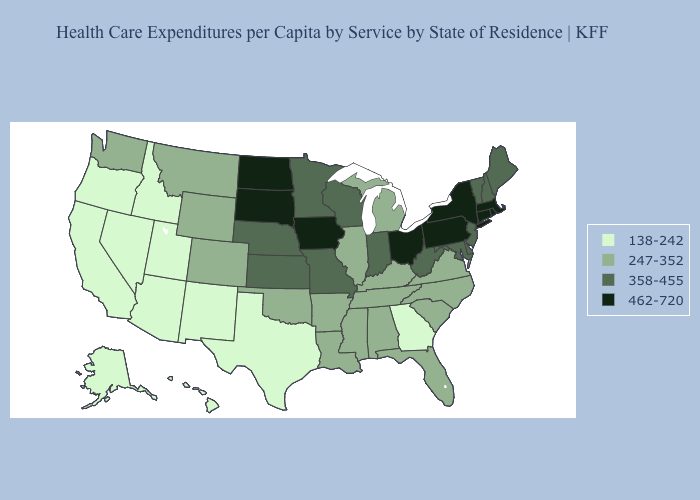What is the value of Michigan?
Keep it brief. 247-352. What is the highest value in states that border Maryland?
Answer briefly. 462-720. Does South Carolina have the lowest value in the South?
Give a very brief answer. No. Which states have the lowest value in the South?
Be succinct. Georgia, Texas. What is the lowest value in states that border Louisiana?
Quick response, please. 138-242. Which states hav the highest value in the Northeast?
Be succinct. Connecticut, Massachusetts, New York, Pennsylvania, Rhode Island. What is the value of Massachusetts?
Quick response, please. 462-720. Does Rhode Island have the highest value in the Northeast?
Concise answer only. Yes. What is the highest value in the Northeast ?
Concise answer only. 462-720. Does Colorado have the lowest value in the USA?
Keep it brief. No. Is the legend a continuous bar?
Short answer required. No. Does New Hampshire have the lowest value in the USA?
Concise answer only. No. What is the value of Arizona?
Write a very short answer. 138-242. What is the value of Kansas?
Answer briefly. 358-455. Does the first symbol in the legend represent the smallest category?
Write a very short answer. Yes. 